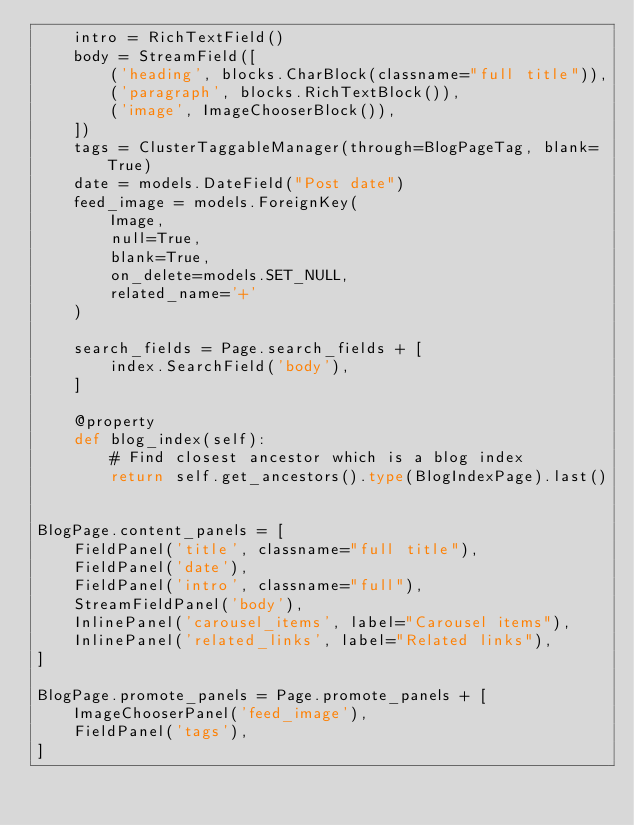Convert code to text. <code><loc_0><loc_0><loc_500><loc_500><_Python_>    intro = RichTextField()
    body = StreamField([
        ('heading', blocks.CharBlock(classname="full title")),
        ('paragraph', blocks.RichTextBlock()),
        ('image', ImageChooserBlock()),
    ])
    tags = ClusterTaggableManager(through=BlogPageTag, blank=True)
    date = models.DateField("Post date")
    feed_image = models.ForeignKey(
        Image,
        null=True,
        blank=True,
        on_delete=models.SET_NULL,
        related_name='+'
    )

    search_fields = Page.search_fields + [
        index.SearchField('body'),
    ]

    @property
    def blog_index(self):
        # Find closest ancestor which is a blog index
        return self.get_ancestors().type(BlogIndexPage).last()


BlogPage.content_panels = [
    FieldPanel('title', classname="full title"),
    FieldPanel('date'),
    FieldPanel('intro', classname="full"),
    StreamFieldPanel('body'),
    InlinePanel('carousel_items', label="Carousel items"),
    InlinePanel('related_links', label="Related links"),
]

BlogPage.promote_panels = Page.promote_panels + [
    ImageChooserPanel('feed_image'),
    FieldPanel('tags'),
]
</code> 